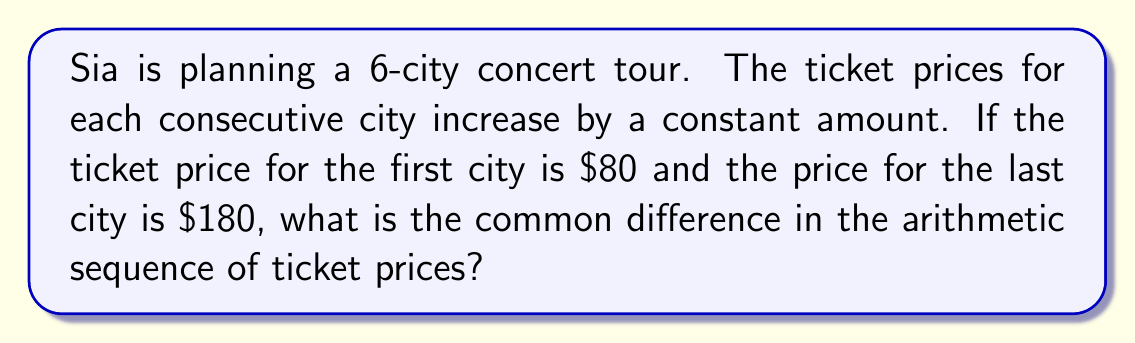Help me with this question. Let's approach this step-by-step:

1) We know that this is an arithmetic sequence with 6 terms (one for each city).

2) Let's define our variables:
   $a_1 = 80$ (first term)
   $a_6 = 180$ (last term)
   $d$ = common difference (what we need to find)
   $n = 6$ (number of terms)

3) In an arithmetic sequence, the last term can be expressed as:
   $a_n = a_1 + (n-1)d$

4) Substituting our known values:
   $180 = 80 + (6-1)d$

5) Simplify:
   $180 = 80 + 5d$

6) Subtract 80 from both sides:
   $100 = 5d$

7) Divide both sides by 5:
   $20 = d$

Therefore, the common difference in the ticket prices is $20.
Answer: $20 